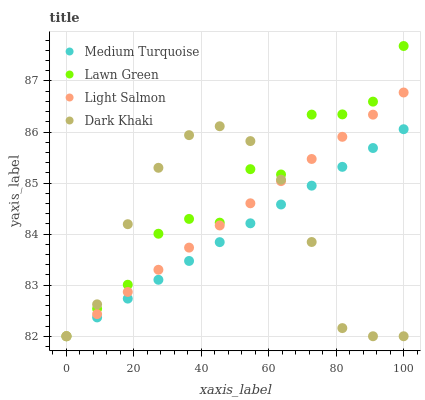Does Medium Turquoise have the minimum area under the curve?
Answer yes or no. Yes. Does Lawn Green have the maximum area under the curve?
Answer yes or no. Yes. Does Light Salmon have the minimum area under the curve?
Answer yes or no. No. Does Light Salmon have the maximum area under the curve?
Answer yes or no. No. Is Medium Turquoise the smoothest?
Answer yes or no. Yes. Is Lawn Green the roughest?
Answer yes or no. Yes. Is Light Salmon the smoothest?
Answer yes or no. No. Is Light Salmon the roughest?
Answer yes or no. No. Does Dark Khaki have the lowest value?
Answer yes or no. Yes. Does Lawn Green have the highest value?
Answer yes or no. Yes. Does Light Salmon have the highest value?
Answer yes or no. No. Does Medium Turquoise intersect Light Salmon?
Answer yes or no. Yes. Is Medium Turquoise less than Light Salmon?
Answer yes or no. No. Is Medium Turquoise greater than Light Salmon?
Answer yes or no. No. 